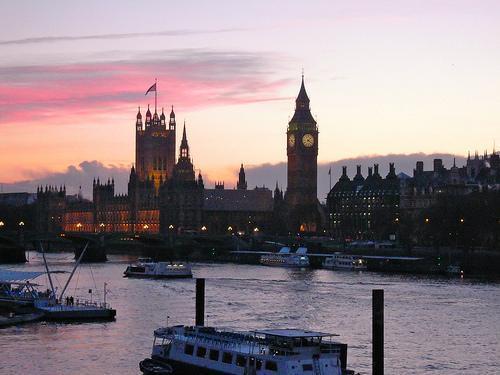How many boats are there?
Give a very brief answer. 4. How many windows can you see on the closest boat?
Give a very brief answer. 7. 